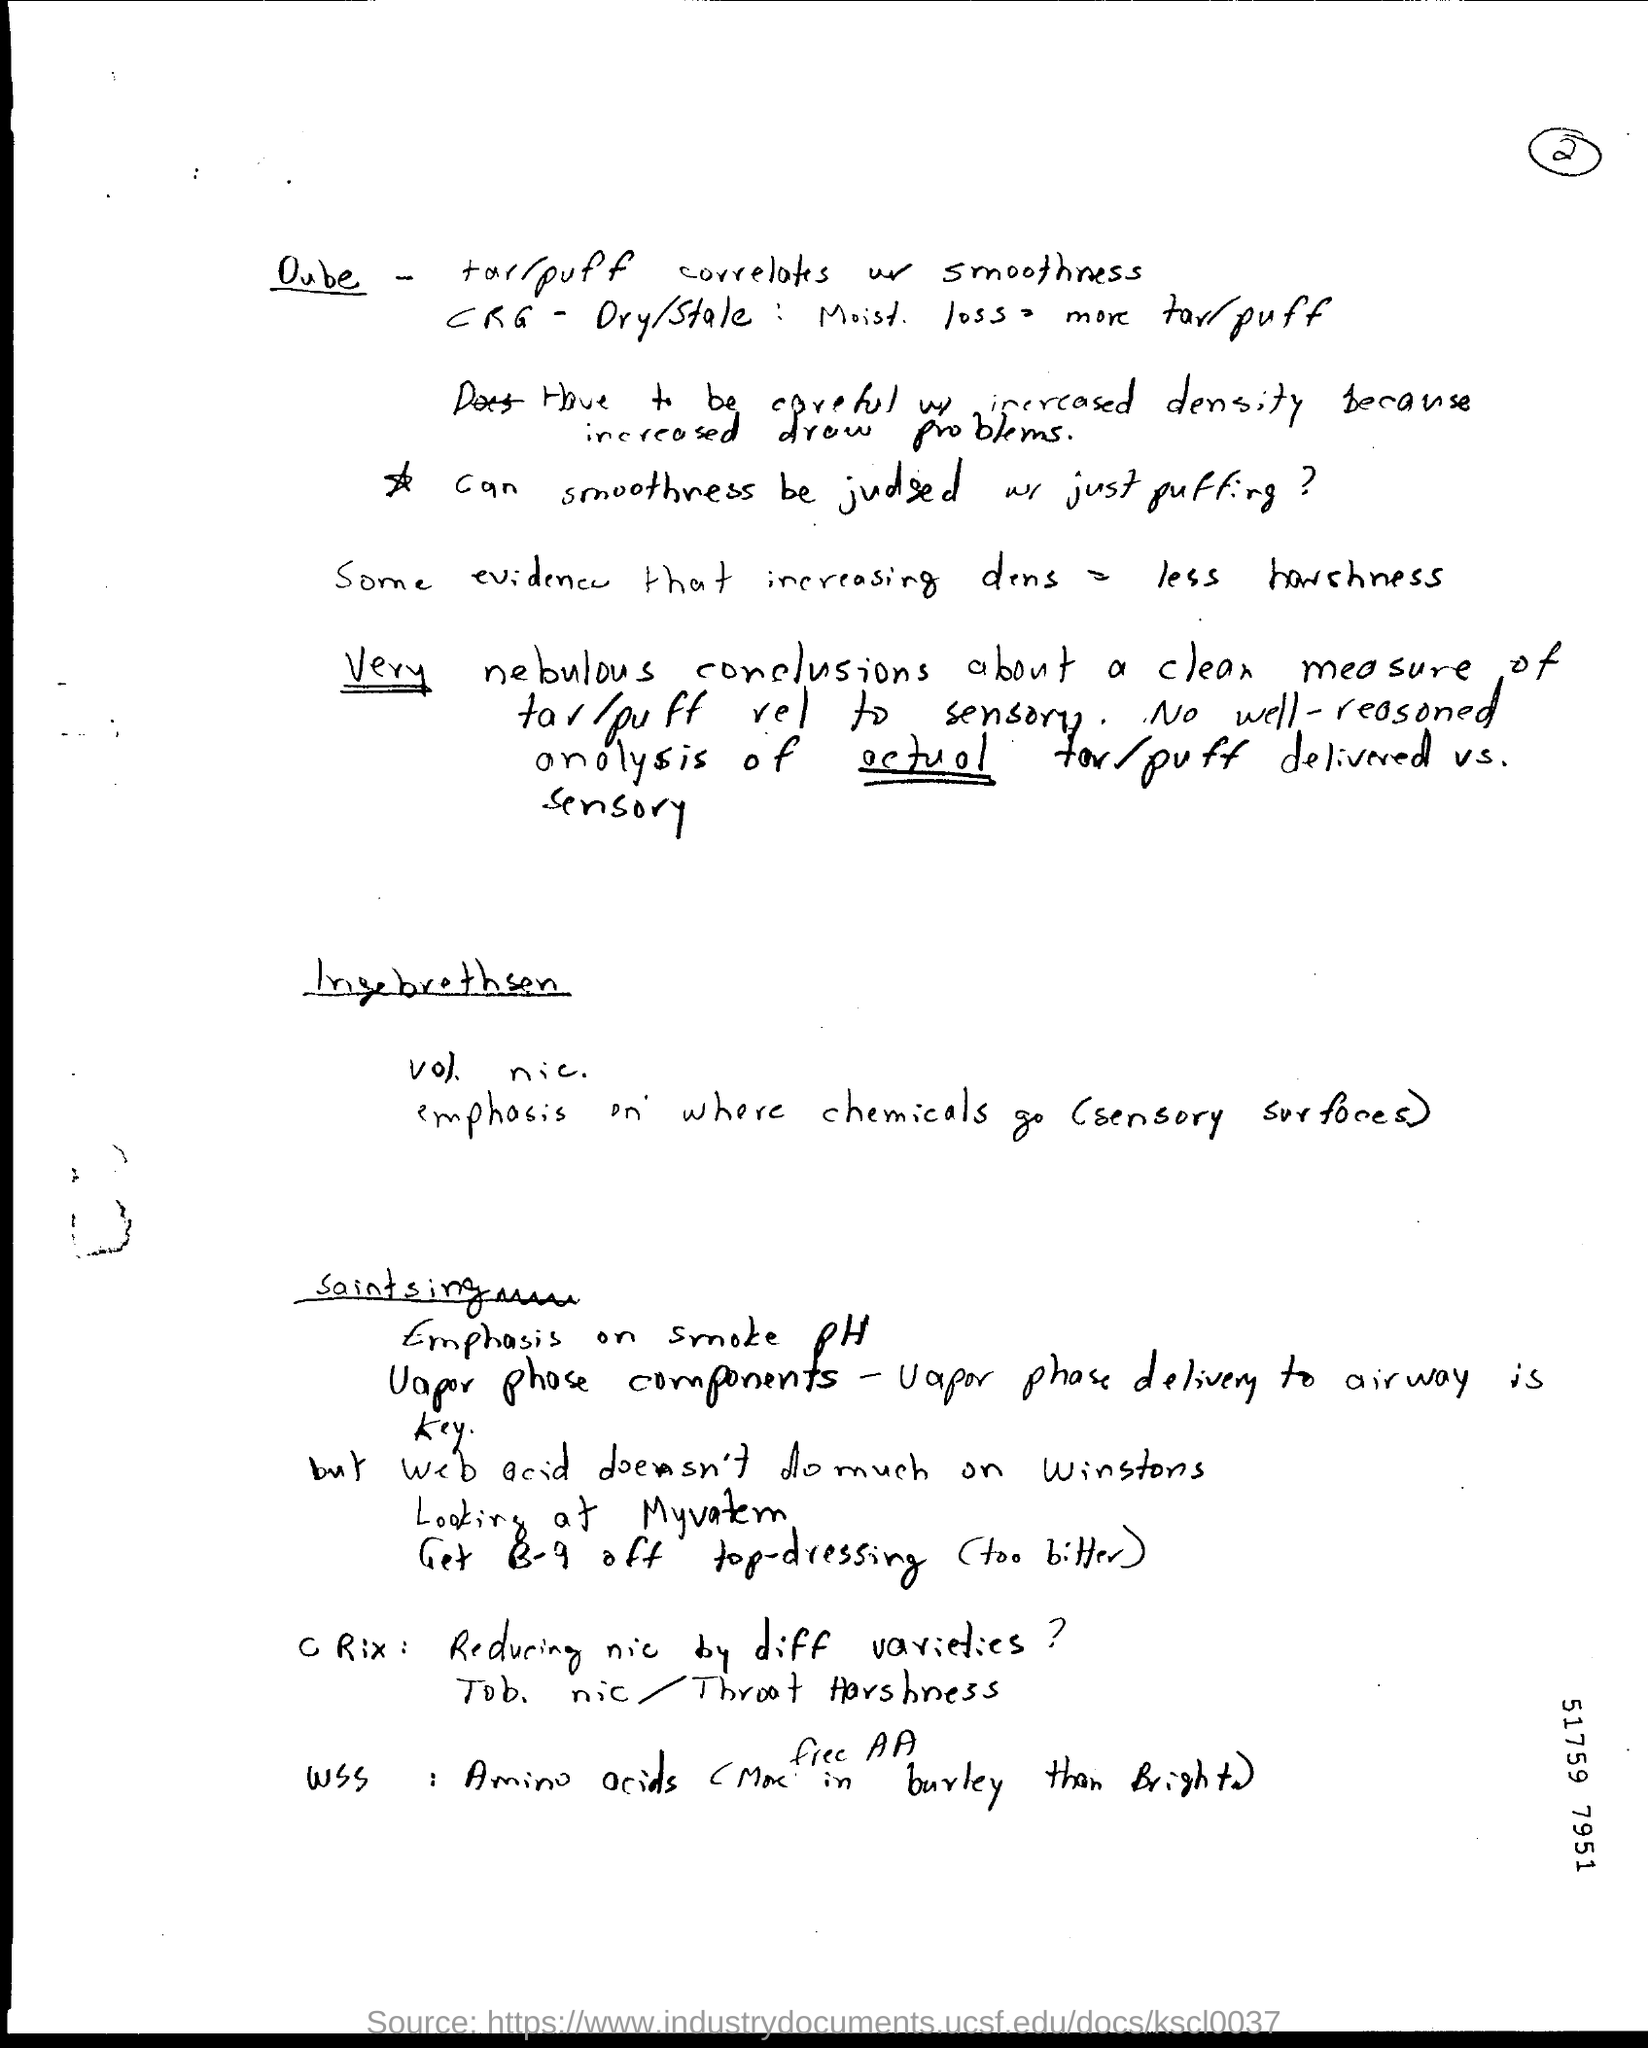What is the page no mentioned in this document?
Your answer should be very brief. 2. What is the number specified on the bottom right side of the document?
Ensure brevity in your answer.  51759 7951. 